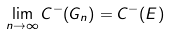<formula> <loc_0><loc_0><loc_500><loc_500>\lim _ { n \to \infty } C ^ { - } ( G _ { n } ) = C ^ { - } ( E )</formula> 